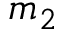<formula> <loc_0><loc_0><loc_500><loc_500>m _ { 2 }</formula> 